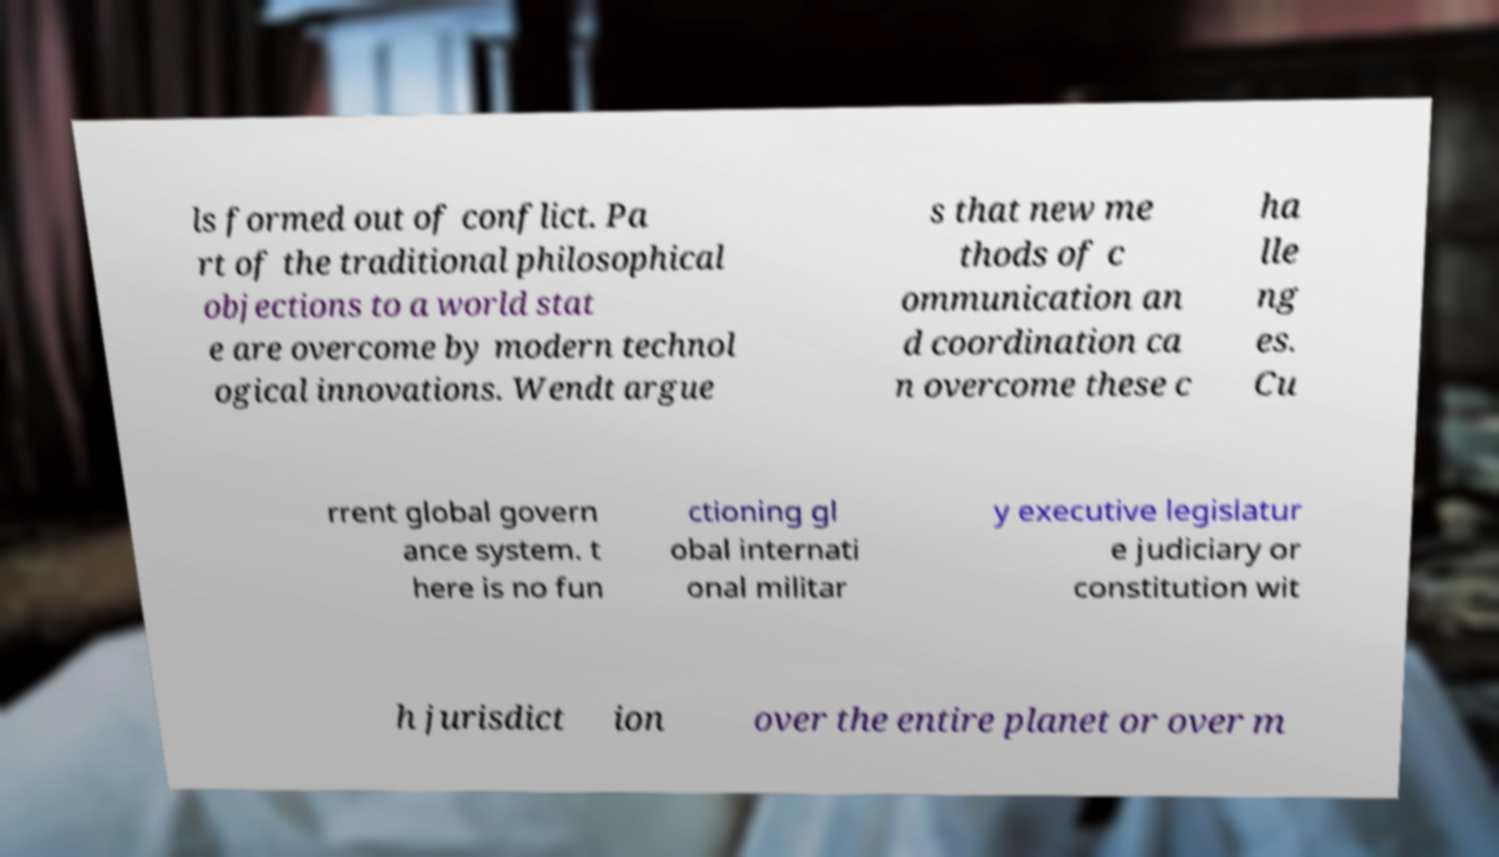Could you extract and type out the text from this image? ls formed out of conflict. Pa rt of the traditional philosophical objections to a world stat e are overcome by modern technol ogical innovations. Wendt argue s that new me thods of c ommunication an d coordination ca n overcome these c ha lle ng es. Cu rrent global govern ance system. t here is no fun ctioning gl obal internati onal militar y executive legislatur e judiciary or constitution wit h jurisdict ion over the entire planet or over m 